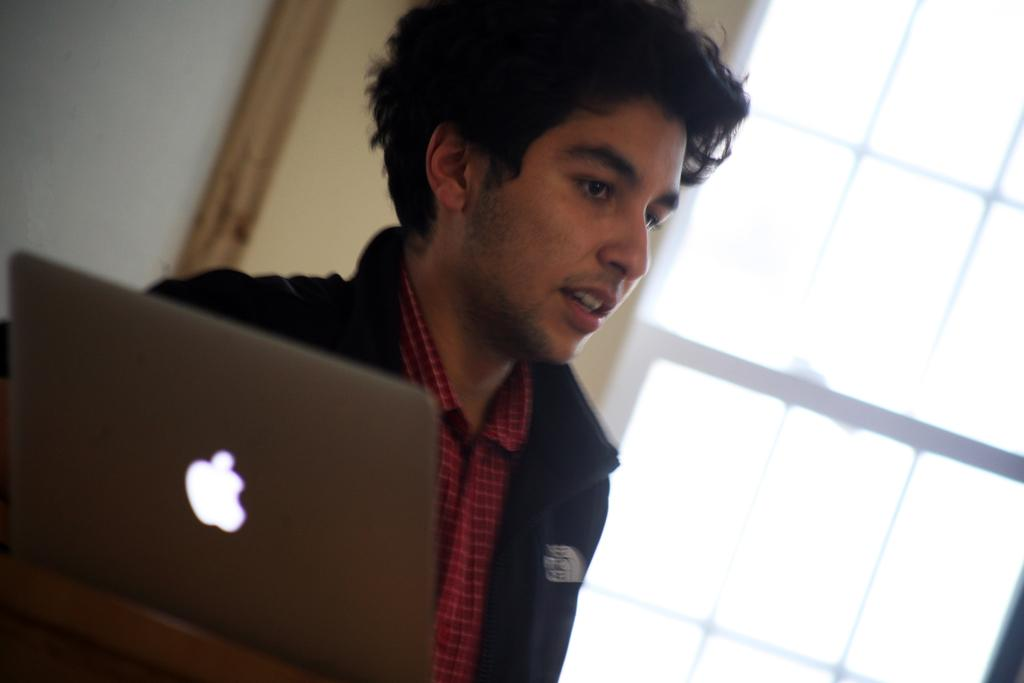What is the main subject of the image? There is a person in the image. What object is located on the left side of the image? There is a laptop on the left side of the image. What can be seen in the background of the image? There is a wall in the background of the image. Is there any natural light source visible in the image? Yes, there is a window in the image. What type of corn can be seen growing near the person in the image? There is no corn present in the image. Is there a lettuce plant visible on the wall in the background? There is no lettuce plant visible in the image. 